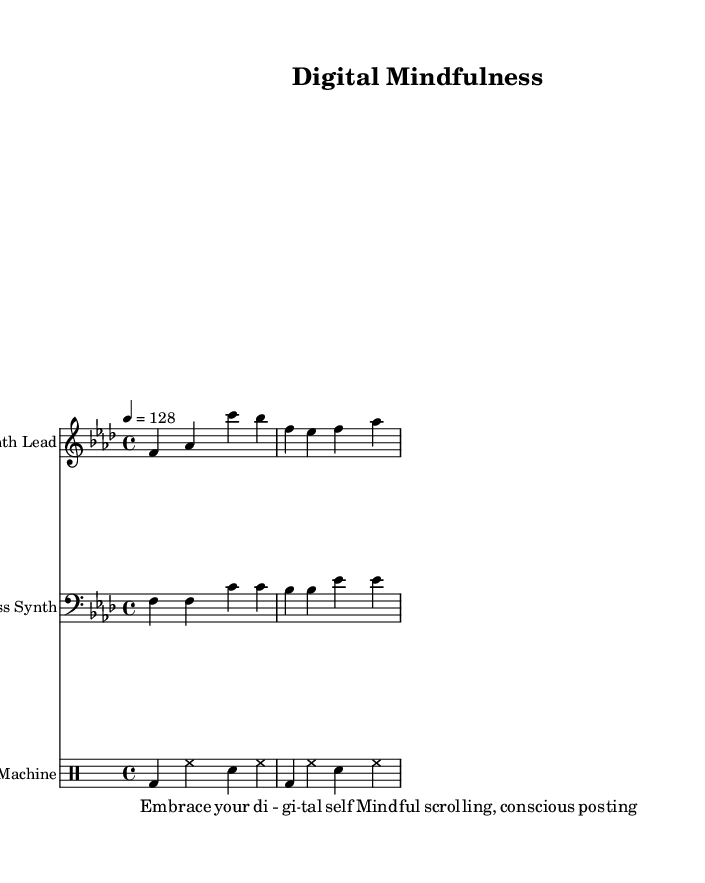What is the key signature of this music? The key signature is indicated at the beginning of the staff. In this score, it shows one flat (B♭), which corresponds to F minor.
Answer: F minor What is the time signature of the piece? The time signature is indicated at the beginning of the score and shows four beats per measure, which is represented as 4/4.
Answer: 4/4 What is the tempo marking for this dance piece? The tempo is marked at the beginning of the score with a metronome mark indicating that it should be played at 128 beats per minute.
Answer: 128 How many measures are in the synth lead part? By counting the groups of notes separated by bar lines in the synth lead section, we see there are two measures presented in the two lines.
Answer: 2 What pattern does the bass synth play in the first measure? The bass synth part has a pattern that includes two F notes followed by two C notes, repeating the rhythmic structure found in the measure.
Answer: F, F, C, C Which instruments are used in this score? The score lists specific instruments for each staff: Synth Lead, Bass Synth, and Drum Machine indicating electronic instrumentation typical in dance music.
Answer: Synth Lead, Bass Synth, Drum Machine What theme do the spoken word snippets convey? The snippets in the lyrics suggest a focus on digital self-awareness and mindfulness, particularly in the context of social media, aligning with themes of mental health resilience.
Answer: Digital self-awareness 